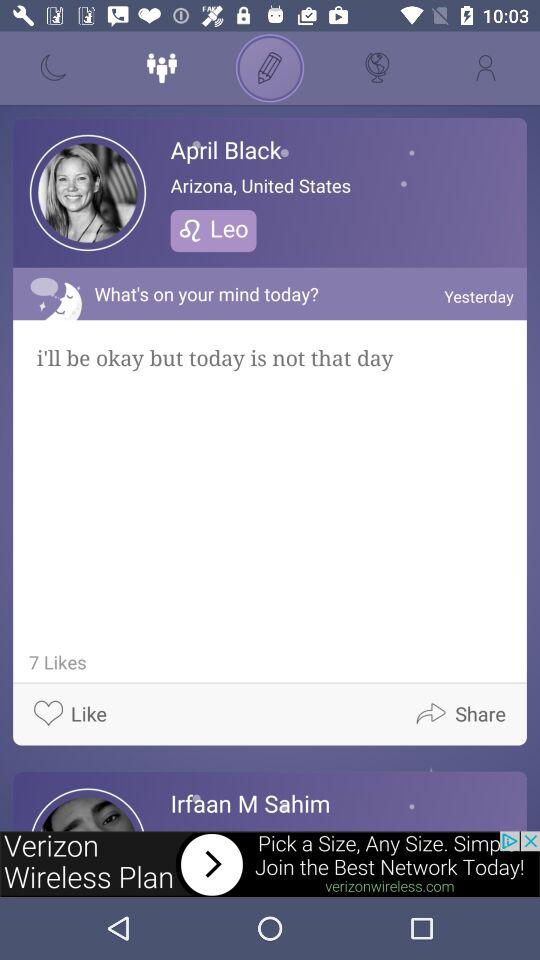What is the total number of likes on the post by April Black? There are a total of 7 likes. 